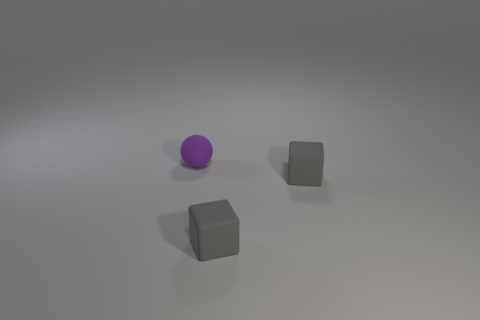Add 1 blocks. How many objects exist? 4 Subtract all spheres. How many objects are left? 2 Subtract all rubber objects. Subtract all big cubes. How many objects are left? 0 Add 2 rubber cubes. How many rubber cubes are left? 4 Add 2 purple rubber balls. How many purple rubber balls exist? 3 Subtract 0 yellow cubes. How many objects are left? 3 